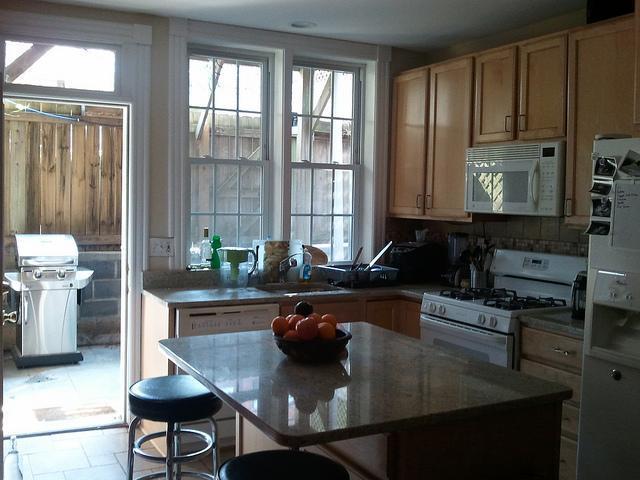How many microwaves are in the photo?
Give a very brief answer. 1. How many chairs can you see?
Give a very brief answer. 2. 